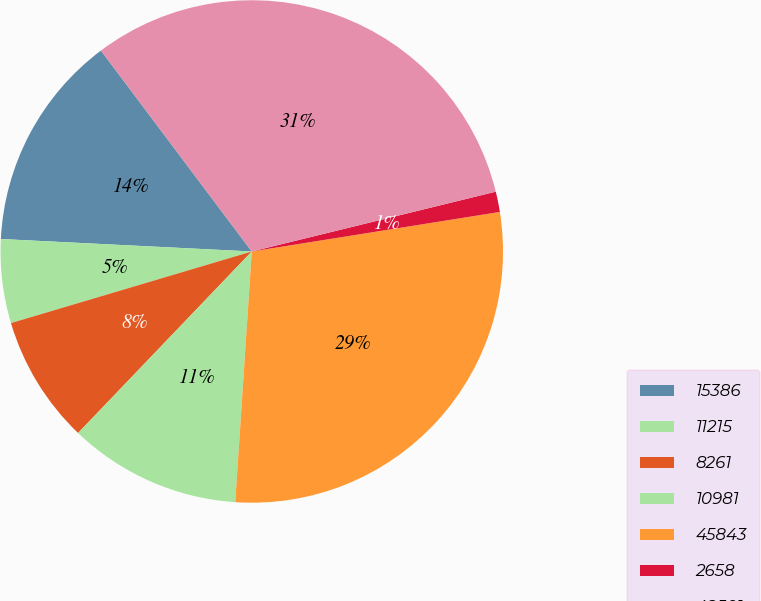Convert chart. <chart><loc_0><loc_0><loc_500><loc_500><pie_chart><fcel>15386<fcel>11215<fcel>8261<fcel>10981<fcel>45843<fcel>2658<fcel>48501<nl><fcel>13.96%<fcel>5.39%<fcel>8.25%<fcel>11.1%<fcel>28.56%<fcel>1.31%<fcel>31.42%<nl></chart> 